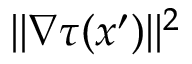Convert formula to latex. <formula><loc_0><loc_0><loc_500><loc_500>| | \nabla \tau ( x ^ { \prime } ) | | ^ { 2 }</formula> 